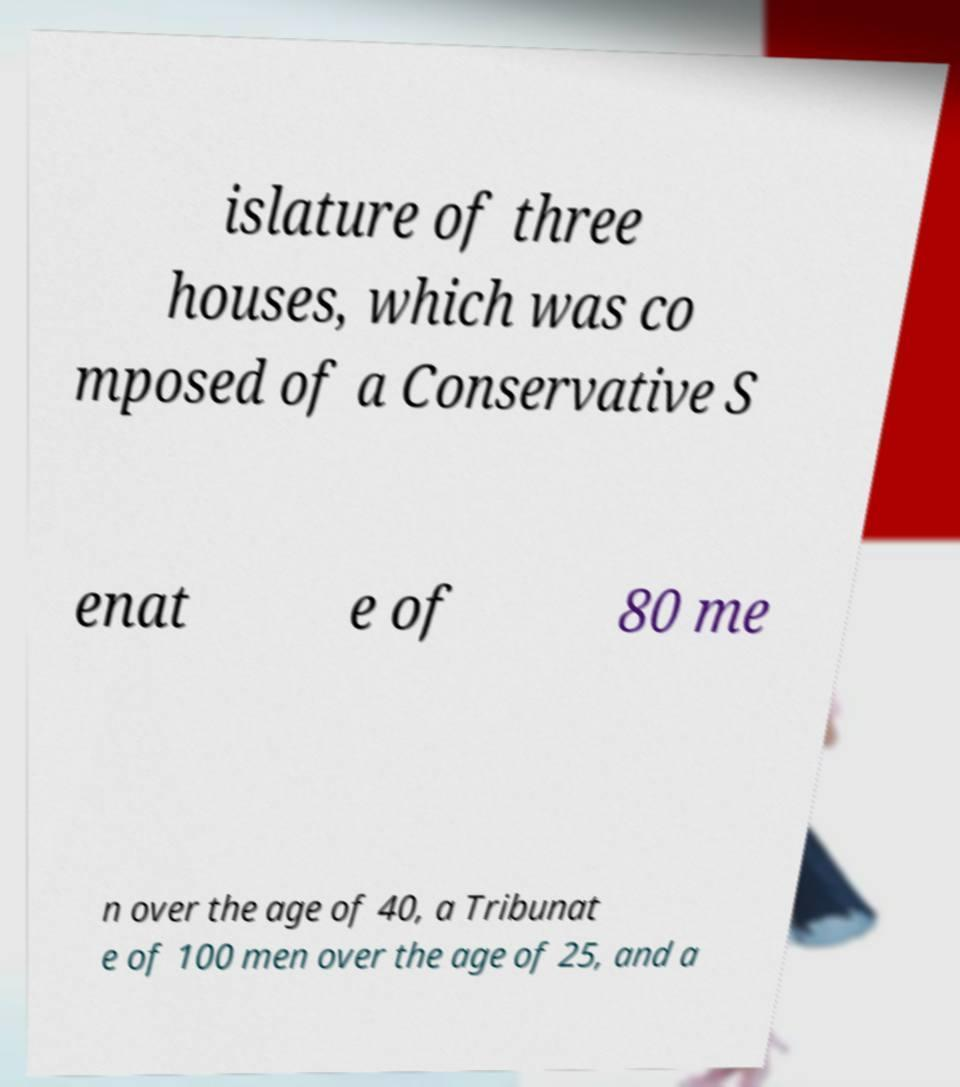Please read and relay the text visible in this image. What does it say? islature of three houses, which was co mposed of a Conservative S enat e of 80 me n over the age of 40, a Tribunat e of 100 men over the age of 25, and a 